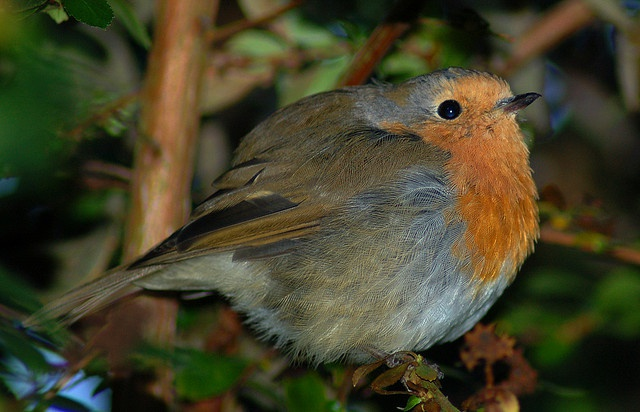Describe the objects in this image and their specific colors. I can see a bird in olive, gray, darkgreen, black, and brown tones in this image. 